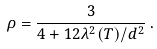Convert formula to latex. <formula><loc_0><loc_0><loc_500><loc_500>\rho = \frac { 3 } { 4 + 1 2 \lambda ^ { 2 } ( T ) / d ^ { 2 } } \, .</formula> 